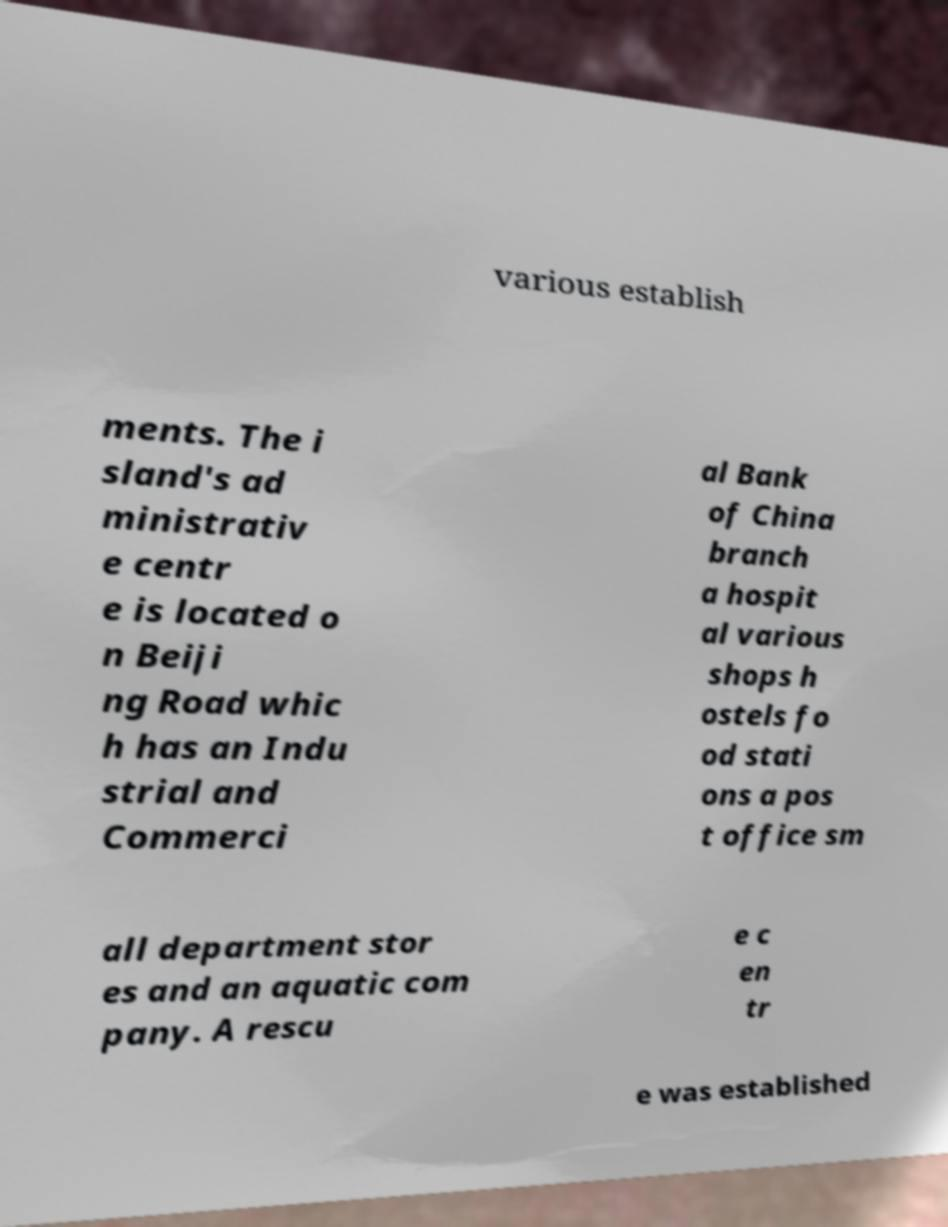I need the written content from this picture converted into text. Can you do that? various establish ments. The i sland's ad ministrativ e centr e is located o n Beiji ng Road whic h has an Indu strial and Commerci al Bank of China branch a hospit al various shops h ostels fo od stati ons a pos t office sm all department stor es and an aquatic com pany. A rescu e c en tr e was established 